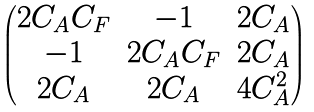Convert formula to latex. <formula><loc_0><loc_0><loc_500><loc_500>\begin{pmatrix} 2 C _ { A } C _ { F } & - 1 & 2 C _ { A } \\ - 1 & 2 C _ { A } C _ { F } & 2 C _ { A } \\ 2 C _ { A } & 2 C _ { A } & 4 C _ { A } ^ { 2 } \end{pmatrix}</formula> 